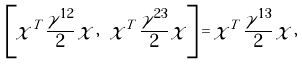Convert formula to latex. <formula><loc_0><loc_0><loc_500><loc_500>\left [ \chi ^ { T } \, \frac { \gamma ^ { 1 2 } } { 2 } \, \chi \, , \ \chi ^ { T } \, \frac { \gamma ^ { 2 3 } } { 2 } \, \chi \right ] = \chi ^ { T } \, \frac { \gamma ^ { 1 3 } } { 2 } \, \chi \, ,</formula> 